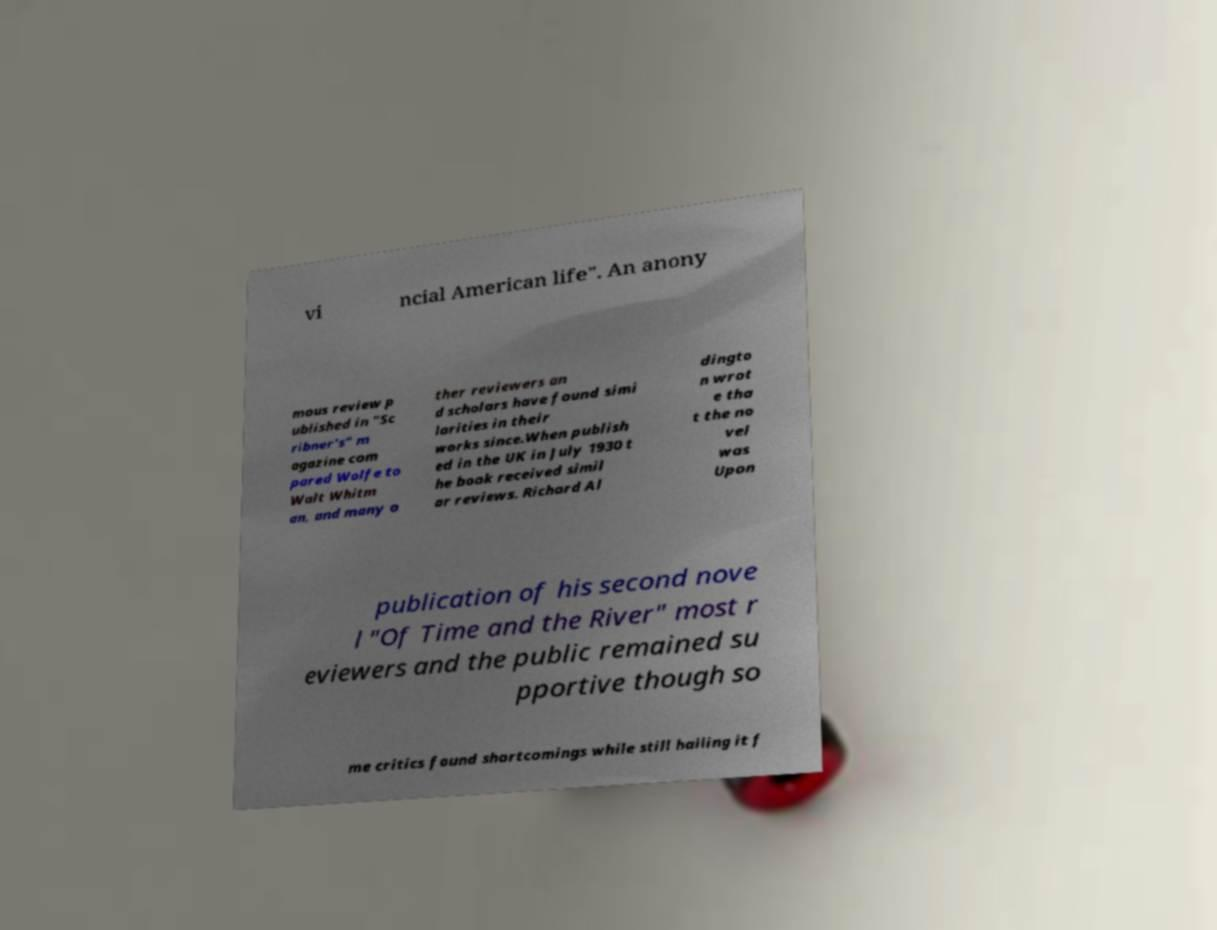I need the written content from this picture converted into text. Can you do that? vi ncial American life". An anony mous review p ublished in "Sc ribner's" m agazine com pared Wolfe to Walt Whitm an, and many o ther reviewers an d scholars have found simi larities in their works since.When publish ed in the UK in July 1930 t he book received simil ar reviews. Richard Al dingto n wrot e tha t the no vel was Upon publication of his second nove l "Of Time and the River" most r eviewers and the public remained su pportive though so me critics found shortcomings while still hailing it f 